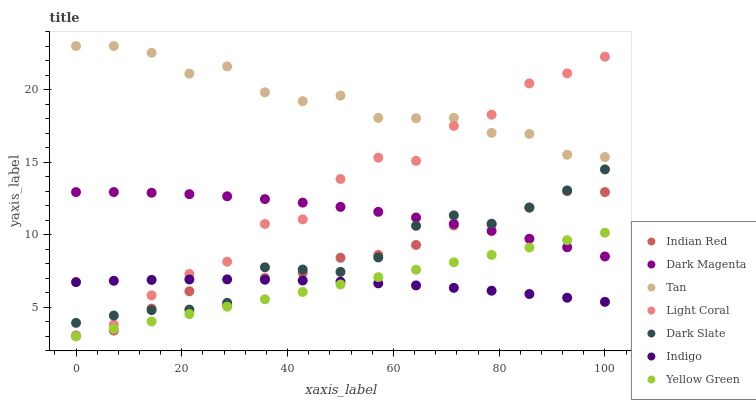Does Indigo have the minimum area under the curve?
Answer yes or no. Yes. Does Tan have the maximum area under the curve?
Answer yes or no. Yes. Does Dark Magenta have the minimum area under the curve?
Answer yes or no. No. Does Dark Magenta have the maximum area under the curve?
Answer yes or no. No. Is Yellow Green the smoothest?
Answer yes or no. Yes. Is Light Coral the roughest?
Answer yes or no. Yes. Is Dark Magenta the smoothest?
Answer yes or no. No. Is Dark Magenta the roughest?
Answer yes or no. No. Does Light Coral have the lowest value?
Answer yes or no. Yes. Does Dark Magenta have the lowest value?
Answer yes or no. No. Does Tan have the highest value?
Answer yes or no. Yes. Does Dark Magenta have the highest value?
Answer yes or no. No. Is Indigo less than Dark Magenta?
Answer yes or no. Yes. Is Tan greater than Indigo?
Answer yes or no. Yes. Does Dark Slate intersect Indian Red?
Answer yes or no. Yes. Is Dark Slate less than Indian Red?
Answer yes or no. No. Is Dark Slate greater than Indian Red?
Answer yes or no. No. Does Indigo intersect Dark Magenta?
Answer yes or no. No. 